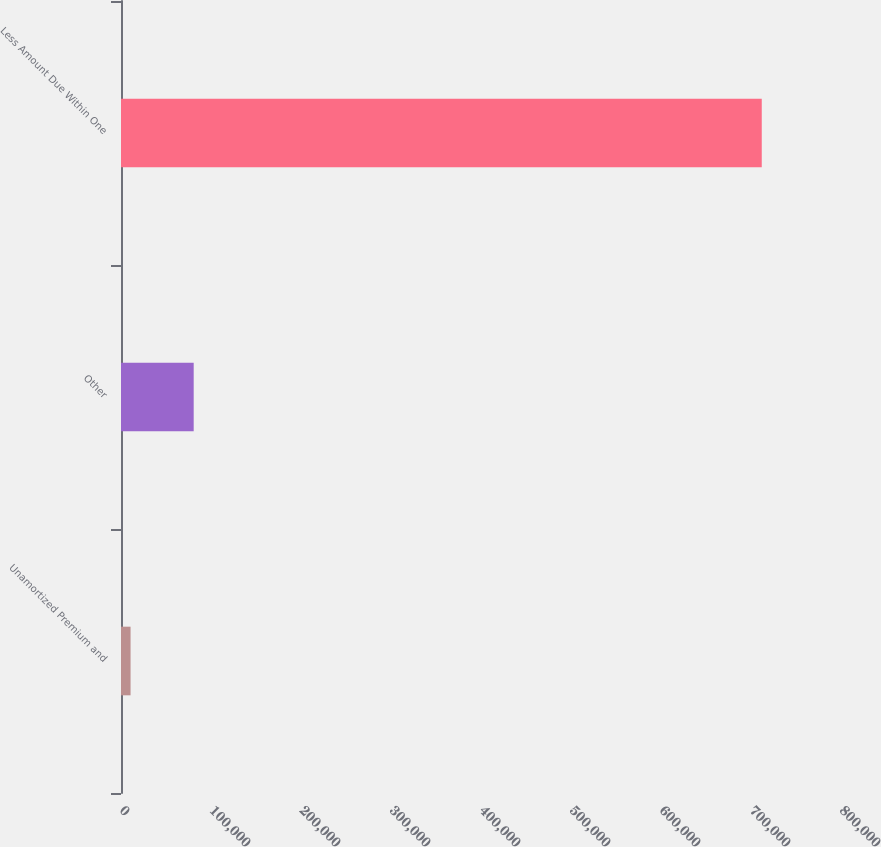Convert chart to OTSL. <chart><loc_0><loc_0><loc_500><loc_500><bar_chart><fcel>Unamortized Premium and<fcel>Other<fcel>Less Amount Due Within One<nl><fcel>10635<fcel>80767.2<fcel>711957<nl></chart> 